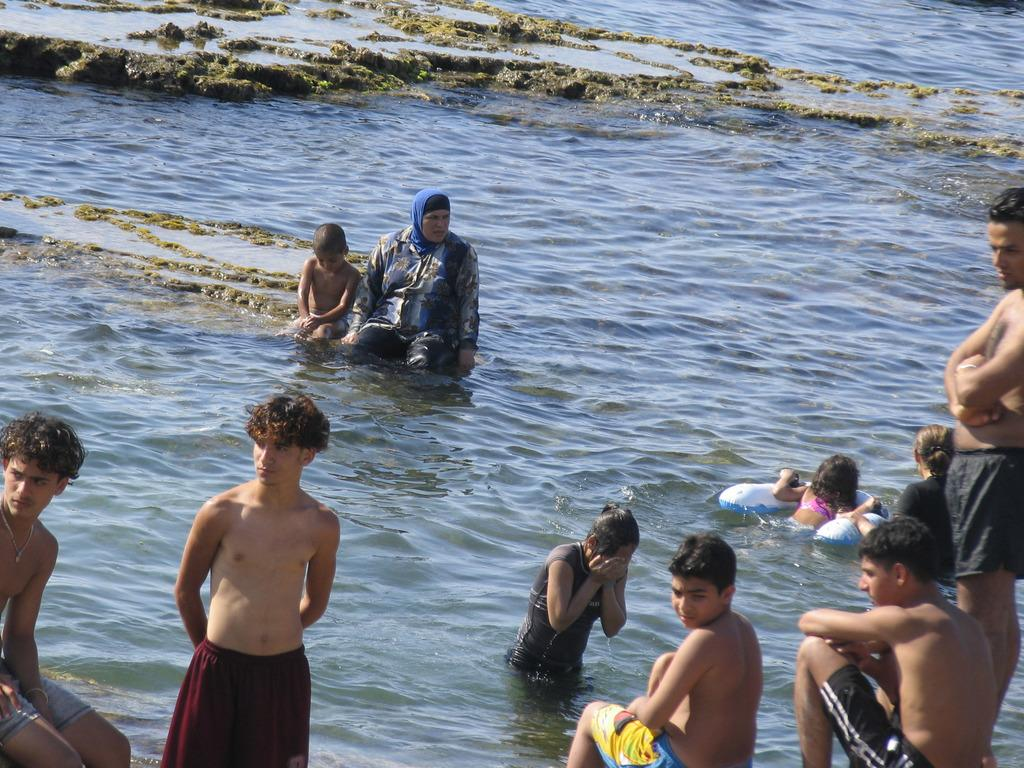How many people are in the image? There is a group of people in the image. What are the people in the image doing? Some people are sitting, while others are standing. What can be seen in the background of the image? There is water visible in the background of the image. What type of doctor is attending to the group of people in the image? There is no doctor present in the image. What is the manager's role in the group of people in the image? There is no manager present in the image. 